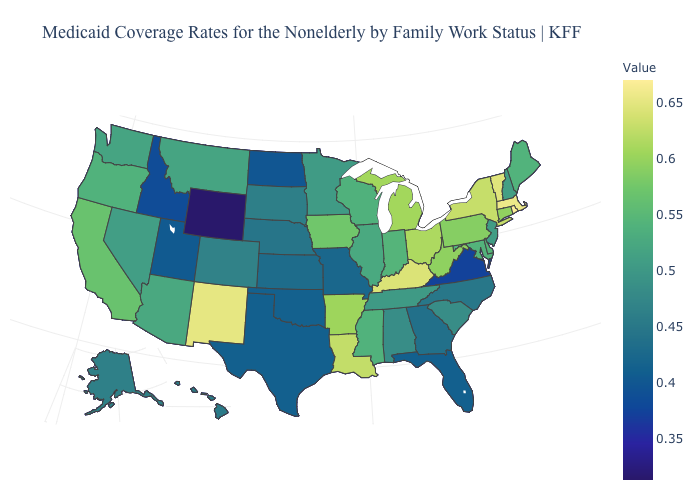Does Nevada have a higher value than New York?
Answer briefly. No. Which states have the lowest value in the USA?
Quick response, please. Wyoming. Does the map have missing data?
Be succinct. No. Among the states that border Nevada , does California have the highest value?
Answer briefly. Yes. Is the legend a continuous bar?
Give a very brief answer. Yes. Does the map have missing data?
Write a very short answer. No. Does Minnesota have the lowest value in the USA?
Concise answer only. No. 